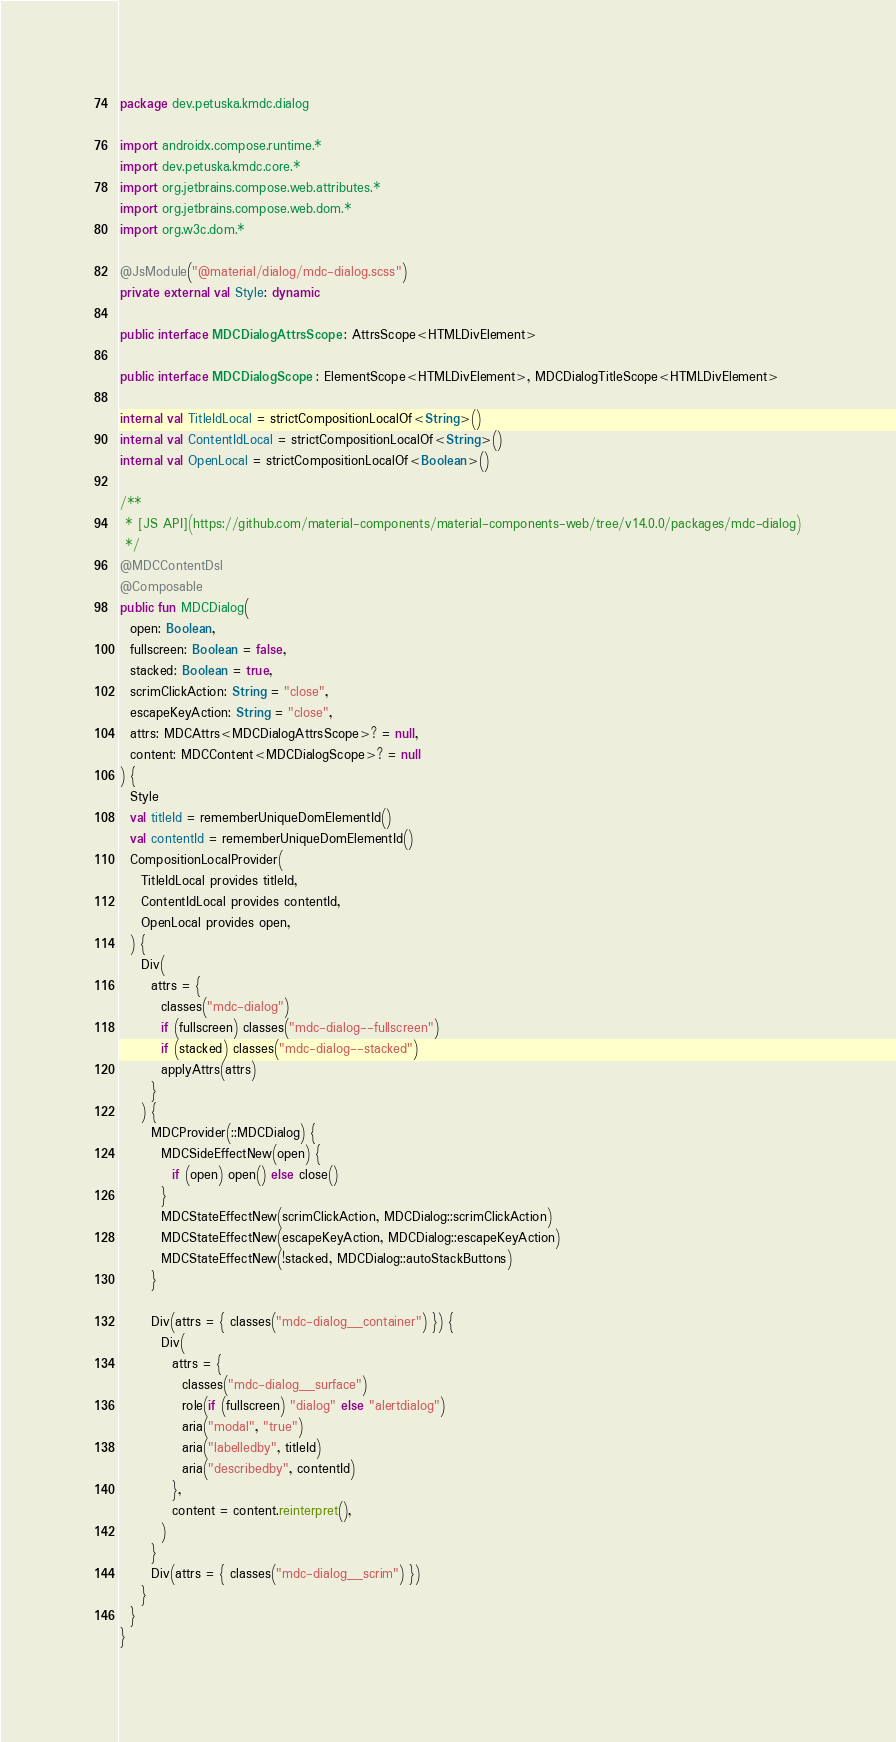<code> <loc_0><loc_0><loc_500><loc_500><_Kotlin_>package dev.petuska.kmdc.dialog

import androidx.compose.runtime.*
import dev.petuska.kmdc.core.*
import org.jetbrains.compose.web.attributes.*
import org.jetbrains.compose.web.dom.*
import org.w3c.dom.*

@JsModule("@material/dialog/mdc-dialog.scss")
private external val Style: dynamic

public interface MDCDialogAttrsScope : AttrsScope<HTMLDivElement>

public interface MDCDialogScope : ElementScope<HTMLDivElement>, MDCDialogTitleScope<HTMLDivElement>

internal val TitleIdLocal = strictCompositionLocalOf<String>()
internal val ContentIdLocal = strictCompositionLocalOf<String>()
internal val OpenLocal = strictCompositionLocalOf<Boolean>()

/**
 * [JS API](https://github.com/material-components/material-components-web/tree/v14.0.0/packages/mdc-dialog)
 */
@MDCContentDsl
@Composable
public fun MDCDialog(
  open: Boolean,
  fullscreen: Boolean = false,
  stacked: Boolean = true,
  scrimClickAction: String = "close",
  escapeKeyAction: String = "close",
  attrs: MDCAttrs<MDCDialogAttrsScope>? = null,
  content: MDCContent<MDCDialogScope>? = null
) {
  Style
  val titleId = rememberUniqueDomElementId()
  val contentId = rememberUniqueDomElementId()
  CompositionLocalProvider(
    TitleIdLocal provides titleId,
    ContentIdLocal provides contentId,
    OpenLocal provides open,
  ) {
    Div(
      attrs = {
        classes("mdc-dialog")
        if (fullscreen) classes("mdc-dialog--fullscreen")
        if (stacked) classes("mdc-dialog--stacked")
        applyAttrs(attrs)
      }
    ) {
      MDCProvider(::MDCDialog) {
        MDCSideEffectNew(open) {
          if (open) open() else close()
        }
        MDCStateEffectNew(scrimClickAction, MDCDialog::scrimClickAction)
        MDCStateEffectNew(escapeKeyAction, MDCDialog::escapeKeyAction)
        MDCStateEffectNew(!stacked, MDCDialog::autoStackButtons)
      }

      Div(attrs = { classes("mdc-dialog__container") }) {
        Div(
          attrs = {
            classes("mdc-dialog__surface")
            role(if (fullscreen) "dialog" else "alertdialog")
            aria("modal", "true")
            aria("labelledby", titleId)
            aria("describedby", contentId)
          },
          content = content.reinterpret(),
        )
      }
      Div(attrs = { classes("mdc-dialog__scrim") })
    }
  }
}
</code> 